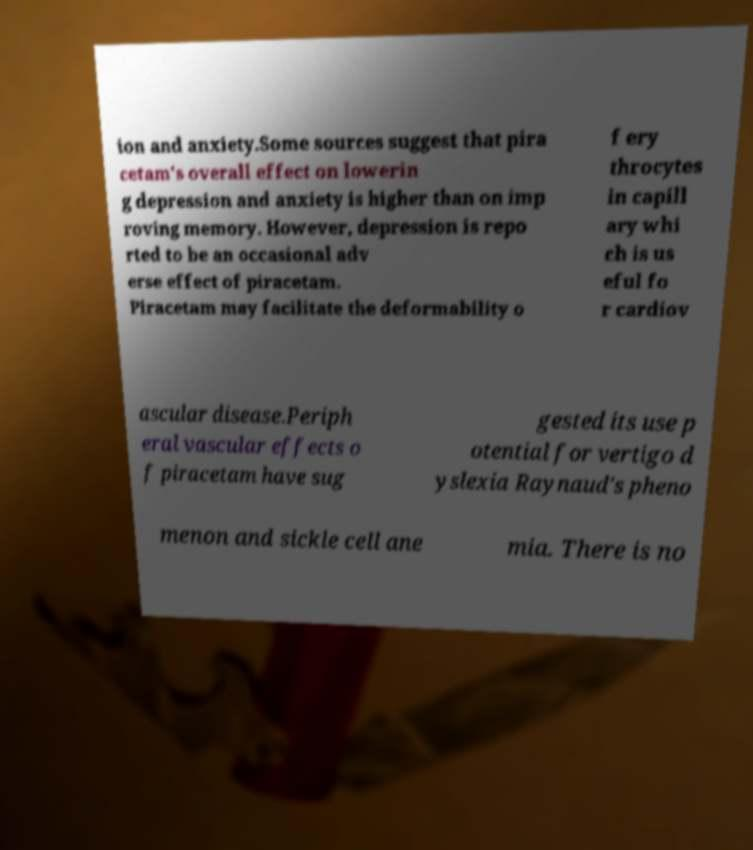What messages or text are displayed in this image? I need them in a readable, typed format. ion and anxiety.Some sources suggest that pira cetam's overall effect on lowerin g depression and anxiety is higher than on imp roving memory. However, depression is repo rted to be an occasional adv erse effect of piracetam. Piracetam may facilitate the deformability o f ery throcytes in capill ary whi ch is us eful fo r cardiov ascular disease.Periph eral vascular effects o f piracetam have sug gested its use p otential for vertigo d yslexia Raynaud's pheno menon and sickle cell ane mia. There is no 